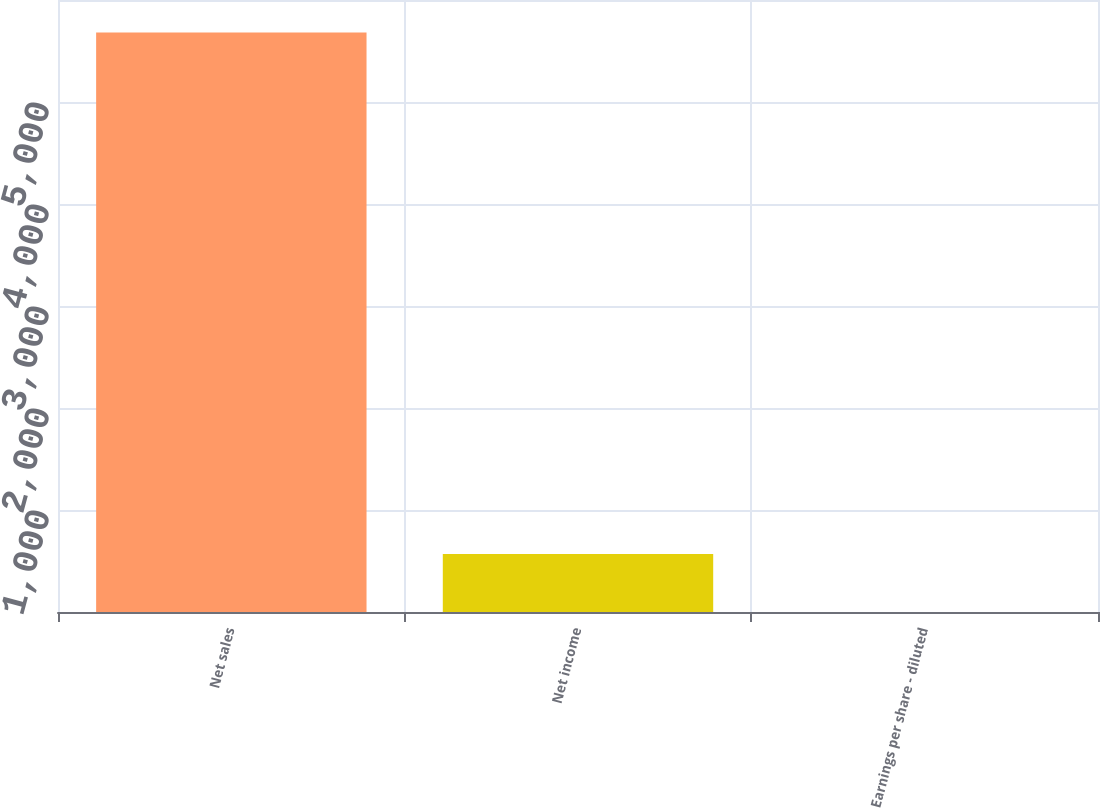Convert chart to OTSL. <chart><loc_0><loc_0><loc_500><loc_500><bar_chart><fcel>Net sales<fcel>Net income<fcel>Earnings per share - diluted<nl><fcel>5682<fcel>568.34<fcel>0.15<nl></chart> 